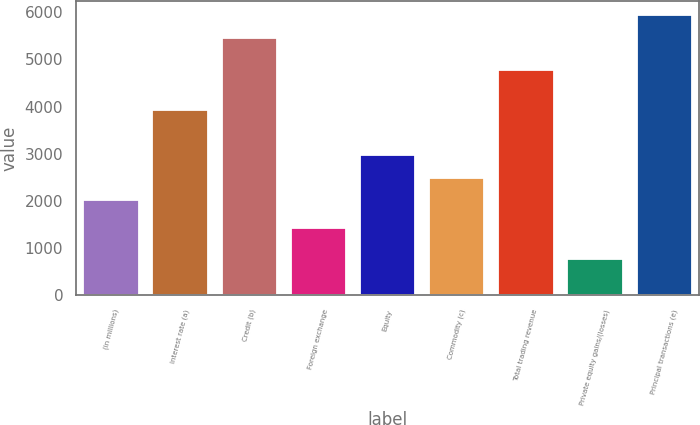<chart> <loc_0><loc_0><loc_500><loc_500><bar_chart><fcel>(in millions)<fcel>Interest rate (a)<fcel>Credit (b)<fcel>Foreign exchange<fcel>Equity<fcel>Commodity (c)<fcel>Total trading revenue<fcel>Private equity gains/(losses)<fcel>Principal transactions (e)<nl><fcel>2012<fcel>3922<fcel>5460<fcel>1436<fcel>2965<fcel>2488.5<fcel>4765<fcel>771<fcel>5936.5<nl></chart> 